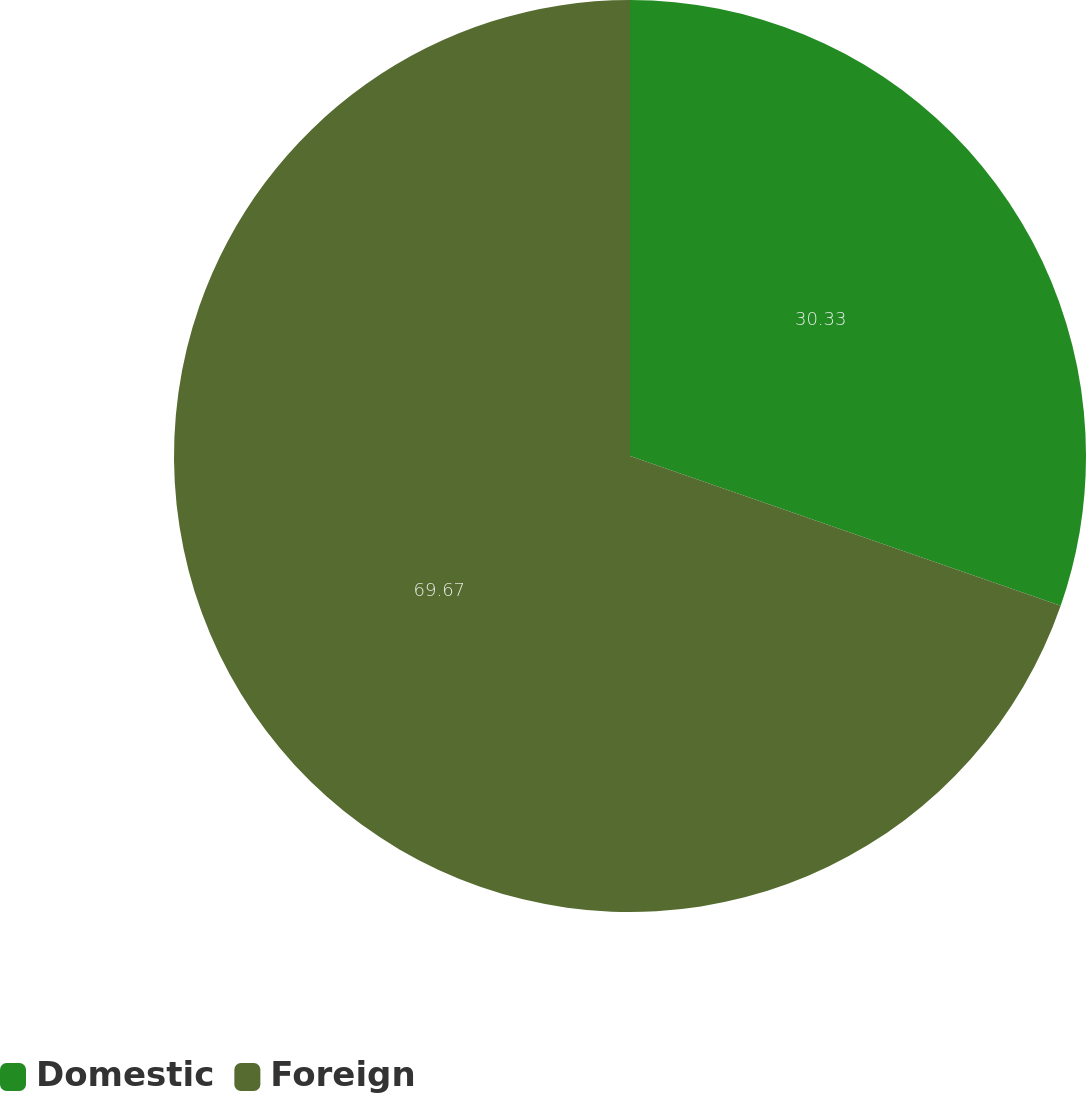Convert chart to OTSL. <chart><loc_0><loc_0><loc_500><loc_500><pie_chart><fcel>Domestic<fcel>Foreign<nl><fcel>30.33%<fcel>69.67%<nl></chart> 